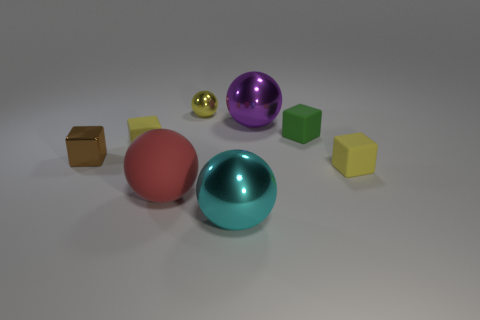Subtract all small green matte cubes. How many cubes are left? 3 Add 1 green metal objects. How many objects exist? 9 Subtract all purple cubes. Subtract all red balls. How many cubes are left? 4 Subtract 0 green balls. How many objects are left? 8 Subtract all small rubber blocks. Subtract all green matte objects. How many objects are left? 4 Add 8 large purple things. How many large purple things are left? 9 Add 6 yellow things. How many yellow things exist? 9 